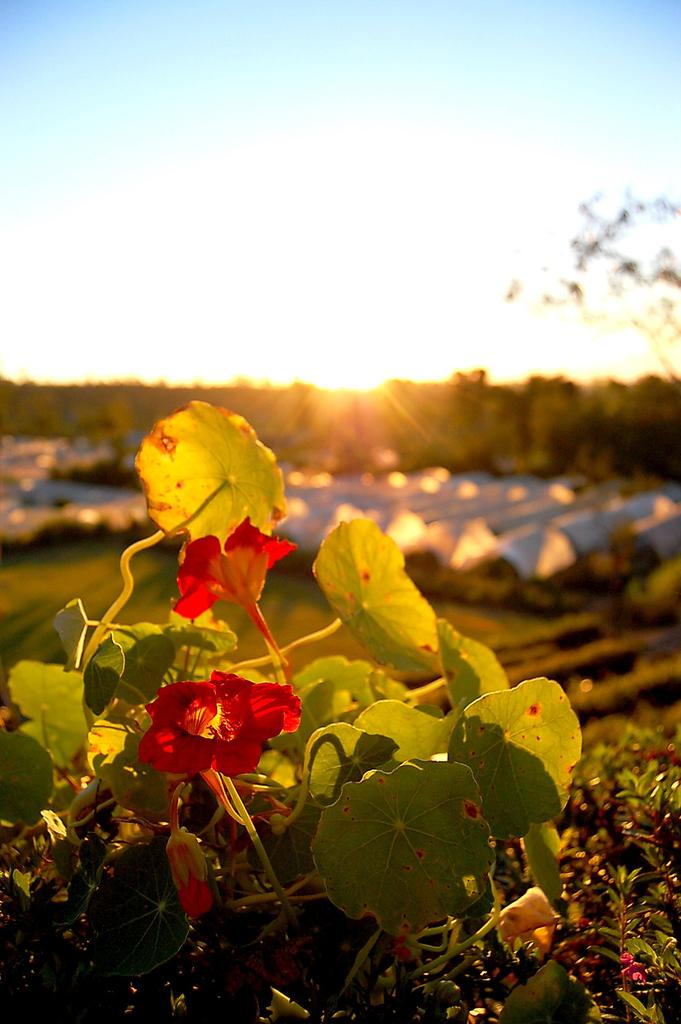What type of plants are at the bottom of the image? There are flowers at the bottom of the image, which belong to creeper plants. What is visible in the sky in the middle of the image? The sun is in the sky in the middle of the image. How does the creeper plant kick the ball in the image? There is no ball present in the image, and creeper plants do not have the ability to kick. 